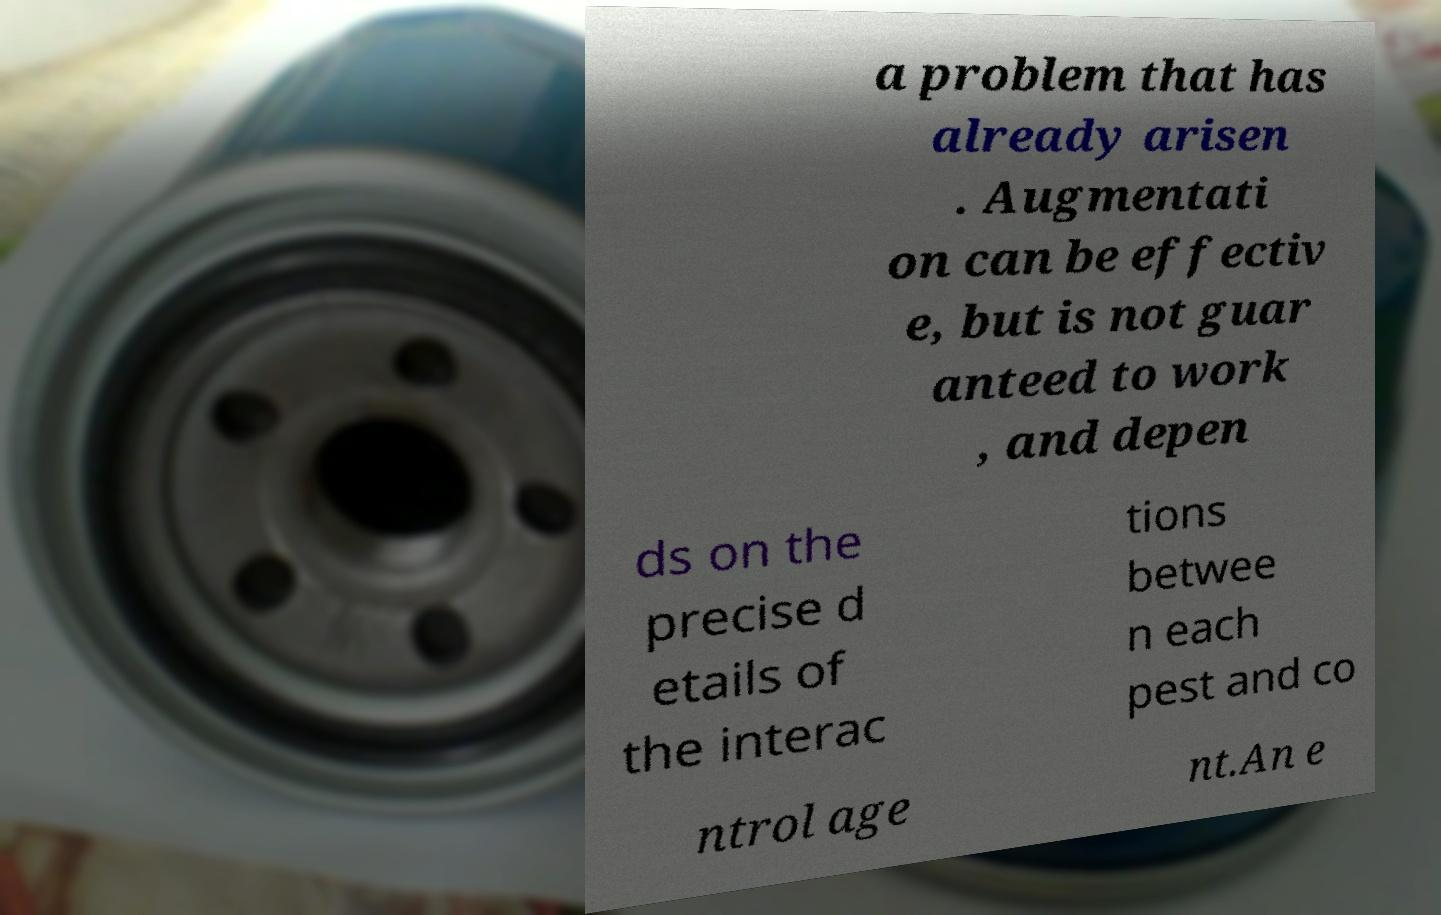Could you assist in decoding the text presented in this image and type it out clearly? a problem that has already arisen . Augmentati on can be effectiv e, but is not guar anteed to work , and depen ds on the precise d etails of the interac tions betwee n each pest and co ntrol age nt.An e 